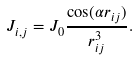Convert formula to latex. <formula><loc_0><loc_0><loc_500><loc_500>J _ { i , j } = J _ { 0 } \frac { \cos ( \alpha r _ { i j } ) } { r _ { i j } ^ { 3 } } .</formula> 